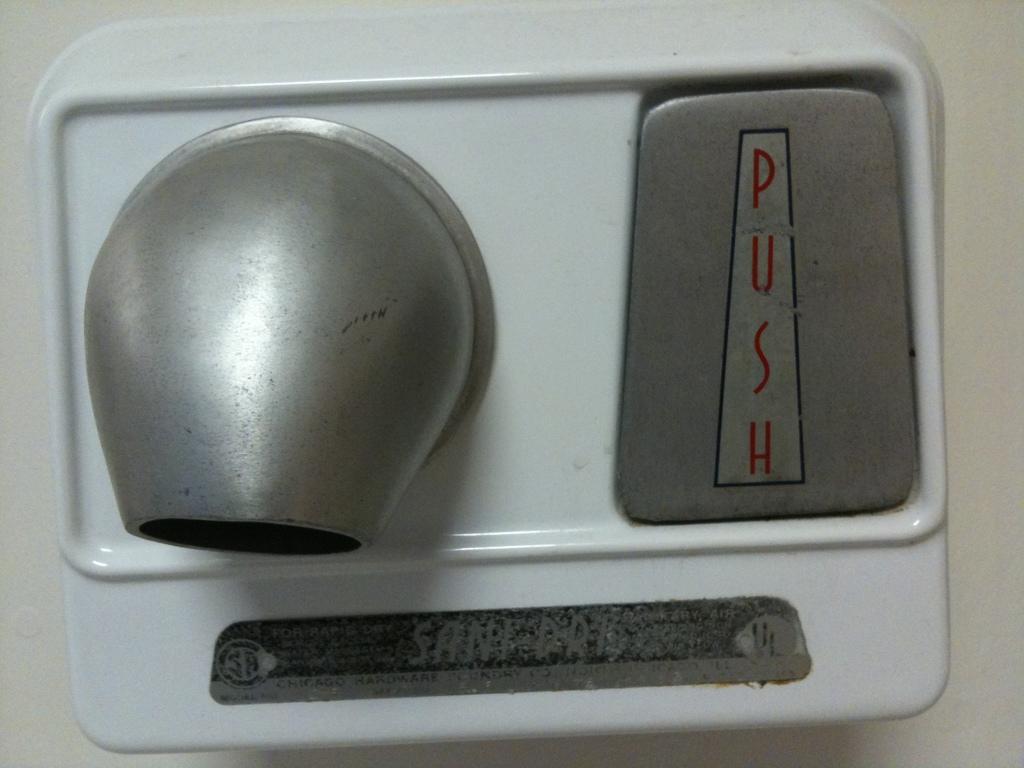Would anyone pull?
Provide a succinct answer. No. What instruction is written in red letters?
Your answer should be compact. Push. 